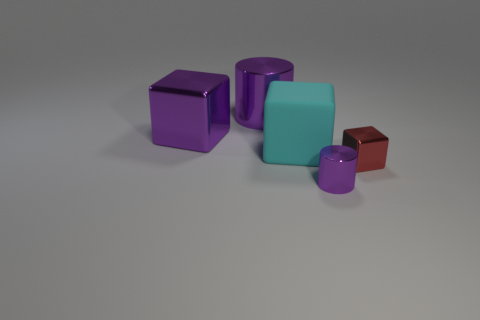Subtract all large cyan rubber blocks. How many blocks are left? 2 Add 1 metallic objects. How many objects exist? 6 Subtract all cylinders. How many objects are left? 3 Subtract all green cubes. Subtract all brown balls. How many cubes are left? 3 Subtract 0 blue blocks. How many objects are left? 5 Subtract all large shiny cylinders. Subtract all large blue rubber cylinders. How many objects are left? 4 Add 5 big rubber cubes. How many big rubber cubes are left? 6 Add 4 purple metallic cylinders. How many purple metallic cylinders exist? 6 